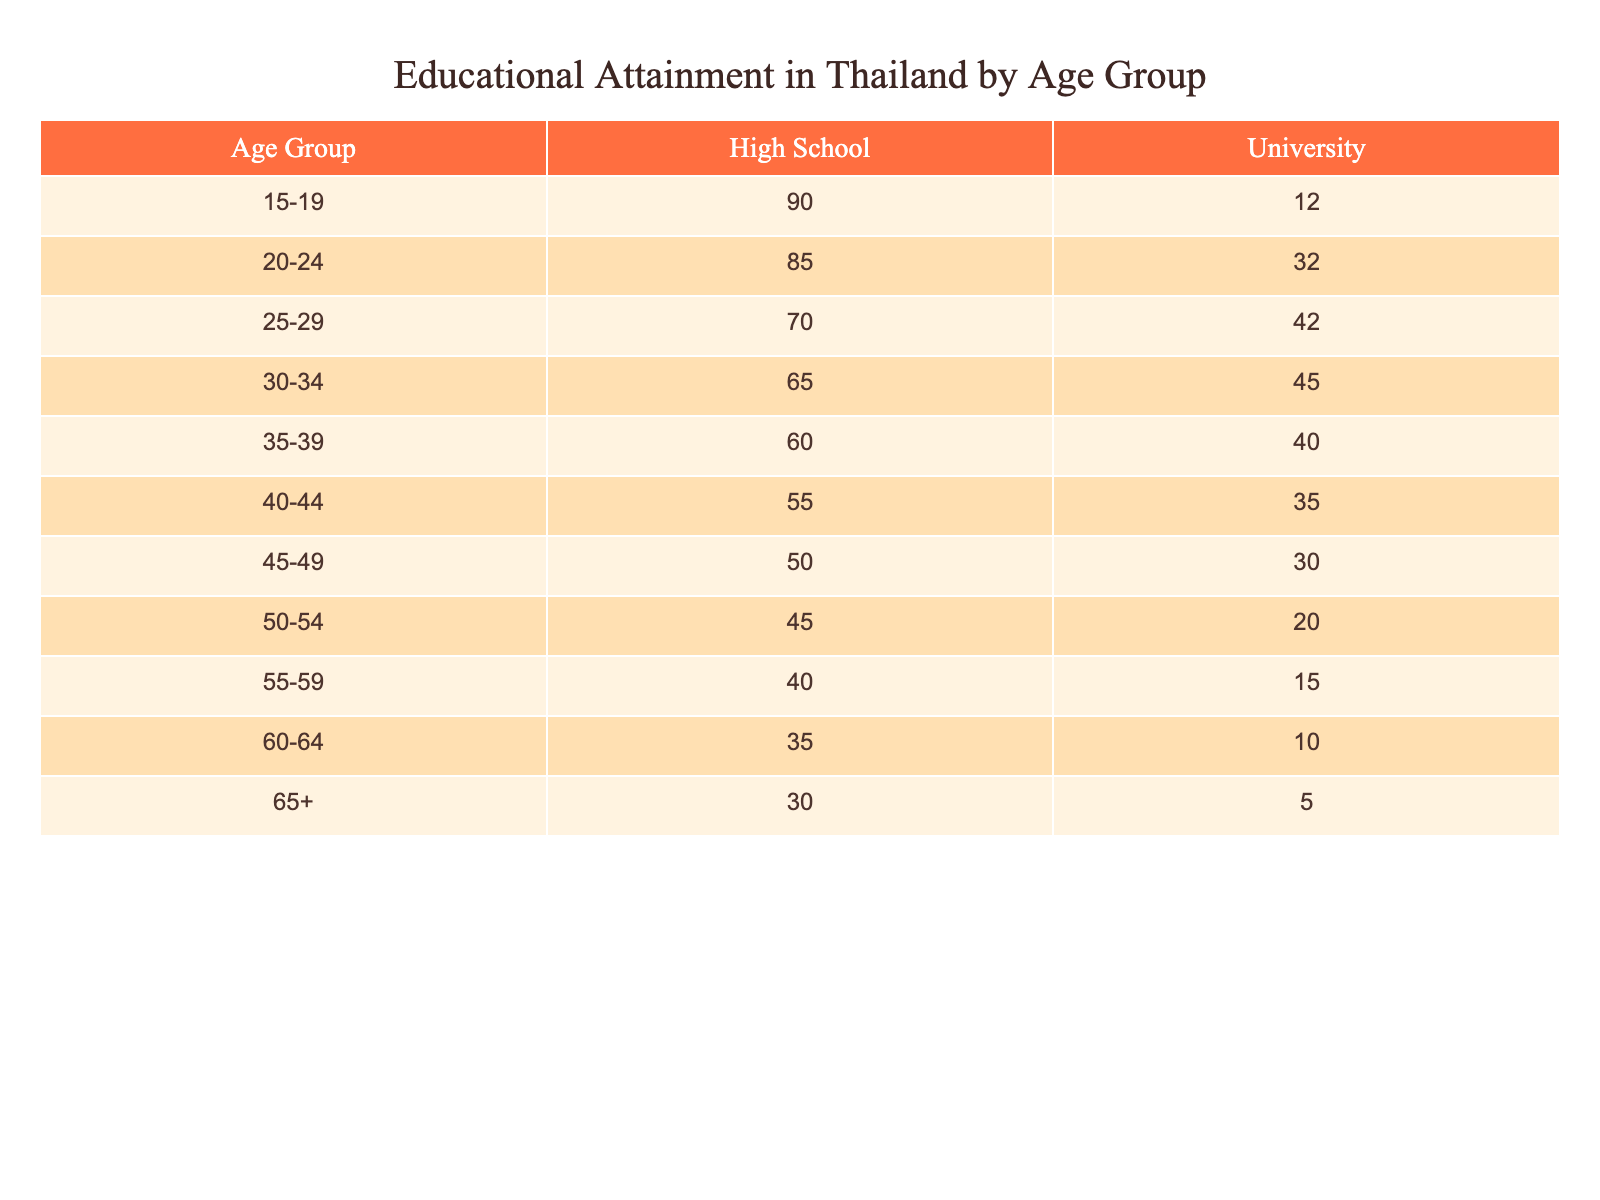What percentage of the 15-19 age group has completed high school? The table shows that 90% of the 15-19 age group has completed high school.
Answer: 90% What is the percentage of university attainment for the age group 25-29? The table indicates that 42% of individuals aged 25-29 have attained a university education.
Answer: 42% Is the percentage of university graduates higher in the age group 20-24 or 30-34? The percentage for the 20-24 age group is 32% (university), while for the 30-34 age group, it is 45% (university). Since 45% is higher than 32%, the university attainment is higher in the 30-34 age group.
Answer: Yes What is the total percentage of high school graduates across the age groups 40-44 and 45-49? The percentage for the 40-44 age group is 55% and for the 45-49 age group is 50%. Adding both gives 55 + 50 = 105%.
Answer: 105% Which age group has the lowest percentage of high school completion? The lowest percentage of high school completion is found in the 60-64 age group, with a completion rate of 35%.
Answer: 35% What percentage of individuals aged 65 and older have completed university education? The table shows that only 5% of individuals aged 65 and older have completed university education.
Answer: 5% If we consider all age groups, what is the average percentage of high school completion? Adding the percentages for high school completion across all age groups gives us: 90 + 85 + 70 + 65 + 60 + 55 + 50 + 45 + 40 + 35 + 30 = 725%. There are 11 age groups, so the average is 725/11 ≈ 65.91%.
Answer: 65.91% Is it true that the percentage of university educated individuals decreases with age, starting from the 15-19 to the 60-64 age group? To evaluate this, we need to look at the percentage of university graduates for these age groups: 12%, 32%, 42%, 45%, 40%, 35%, 30%, 20%, 15%, 10%, and 5%. The series shows a decrease in university attainment as the age increases. Therefore, the statement is true.
Answer: Yes What is the difference in the percentage of university attainment between the 25-29 and 40-44 age groups? The percentage of university attainment for the 25-29 age group is 42%, and for the 40-44 age group, it is 35%. The difference is 42 - 35 = 7%.
Answer: 7% In which age group does the sum of high school and university percentages equal to 100%? For the age group 15-19, the sum of high school (90%) and university (12%) is 90 + 12 = 102%, which does not equal 100%. The calculations for all age groups show that none achieve exactly 100% when summing high school and university percentages due to rounding.
Answer: None 